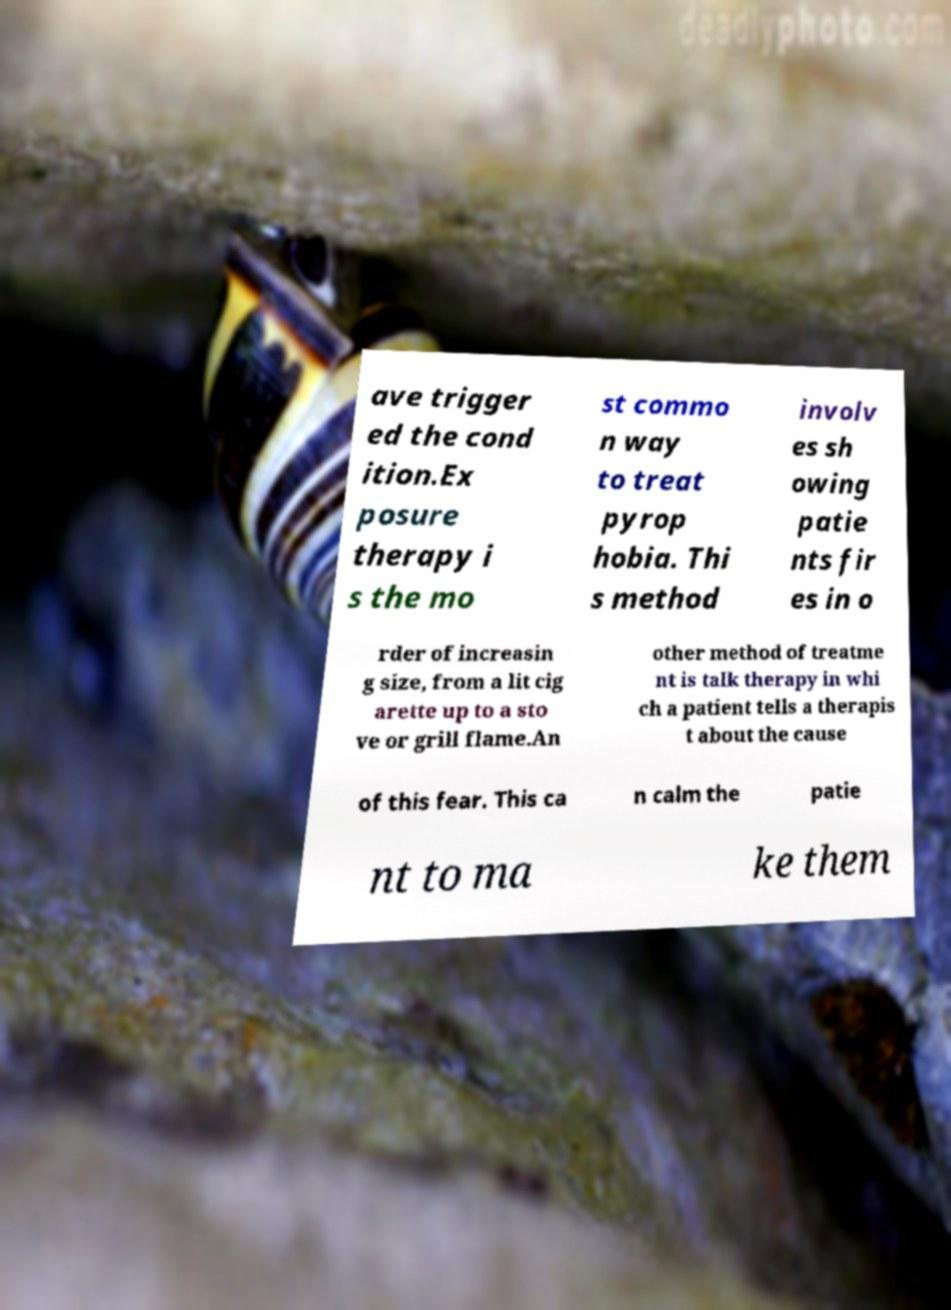Can you read and provide the text displayed in the image?This photo seems to have some interesting text. Can you extract and type it out for me? ave trigger ed the cond ition.Ex posure therapy i s the mo st commo n way to treat pyrop hobia. Thi s method involv es sh owing patie nts fir es in o rder of increasin g size, from a lit cig arette up to a sto ve or grill flame.An other method of treatme nt is talk therapy in whi ch a patient tells a therapis t about the cause of this fear. This ca n calm the patie nt to ma ke them 